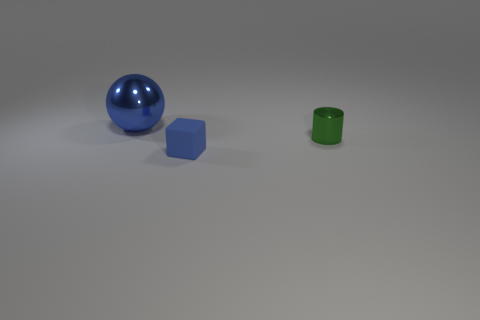Add 3 large cyan metallic cylinders. How many objects exist? 6 Subtract 0 gray balls. How many objects are left? 3 Subtract all cubes. How many objects are left? 2 Subtract 1 cubes. How many cubes are left? 0 Subtract all red spheres. Subtract all red blocks. How many spheres are left? 1 Subtract all small cyan objects. Subtract all metal cylinders. How many objects are left? 2 Add 2 rubber objects. How many rubber objects are left? 3 Add 1 large things. How many large things exist? 2 